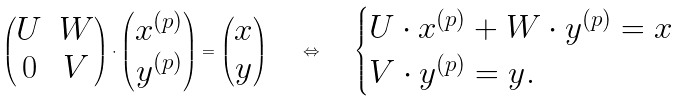Convert formula to latex. <formula><loc_0><loc_0><loc_500><loc_500>\begin{pmatrix} U & W \\ 0 & V \end{pmatrix} \cdot \begin{pmatrix} x ^ { ( p ) } \\ y ^ { ( p ) } \end{pmatrix} = \begin{pmatrix} x \\ y \end{pmatrix} \quad \Leftrightarrow \quad \begin{cases} U \cdot x ^ { ( p ) } + W \cdot y ^ { ( p ) } = x \\ V \cdot y ^ { ( p ) } = y . \end{cases}</formula> 